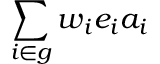Convert formula to latex. <formula><loc_0><loc_0><loc_500><loc_500>\sum _ { i \in g } w _ { i } e _ { i } a _ { i }</formula> 